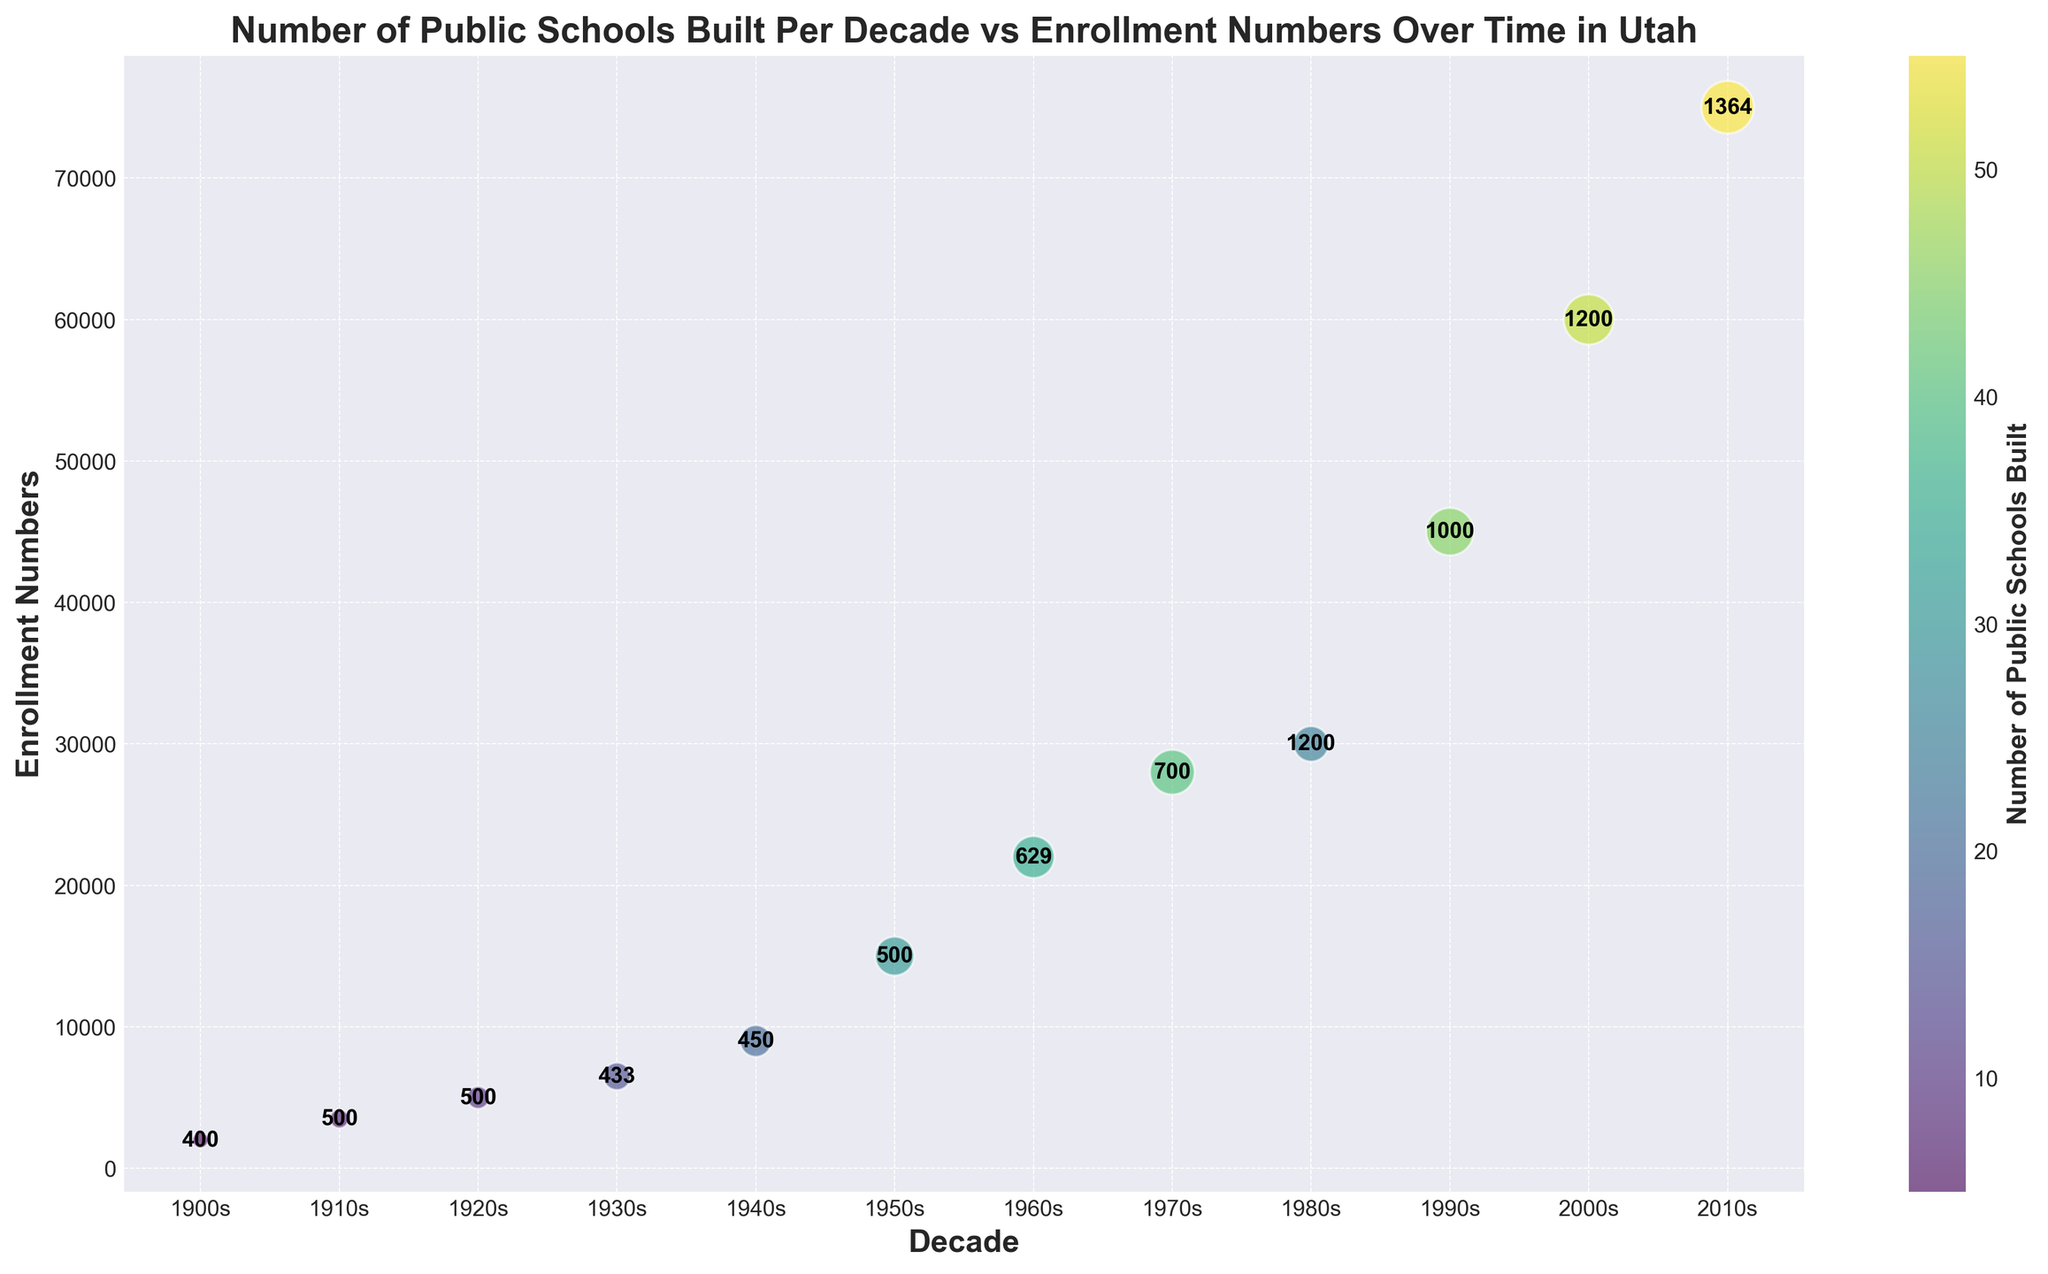What is the general trend of enrollment numbers over time? By observing the figure, you can see that the enrollment numbers have been steadily increasing from the 1900s to the 2010s, indicating growth in student population over time.
Answer: Increasing Which decade saw the highest number of public schools built? Look at the color scale or the size of the bubbles. The 2010s have the largest and darkest bubbles, showing the highest number of public schools built.
Answer: 2010s What is the average school size in the 1980s, and how does it compare to the 1960s? From the figure, find the annotations of average school sizes for the 1980s and 1960s. The 1980s have an average school size of 1200, while the 1960s have an average school size of 629.
Answer: 1200 vs 629 How does the enrollment number in the 1930s compare to the 1940s? Locate the enrollment numbers at the 1930s (6500) and 1940s (9000) on the y-axis and compare them.
Answer: 6500 vs 9000 During which decade was the average school size the smallest? Check the annotations for the smallest number. The 1900s have the smallest average school size of 400.
Answer: 1900s What is the difference in the number of public schools built between the 1950s and the 2010s? Notice the number of schools built in both decades: 30 in the 1950s and 55 in the 2010s. The difference is 55 - 30 = 25.
Answer: 25 How do the public schools built in the 1970s compare to those in the 1980s in terms of size and color of the bubbles? Bubbles for the 1970s should be larger and darker, indicating more public schools built compared to the 1980s.
Answer: Larger and darker What is the total number of public schools built from the 1900s to the 1960s? Sum the number of schools built from 1900s, 1910s, 1920s, 1930s, 1940s, 1950s, and 1960s: 5+7+10+15+20+30+35 = 122.
Answer: 122 What do the different bubble sizes represent in this chart? The bubble sizes are proportional to the number of public schools built in each decade, with larger bubbles representing more schools built.
Answer: Number of public schools built 